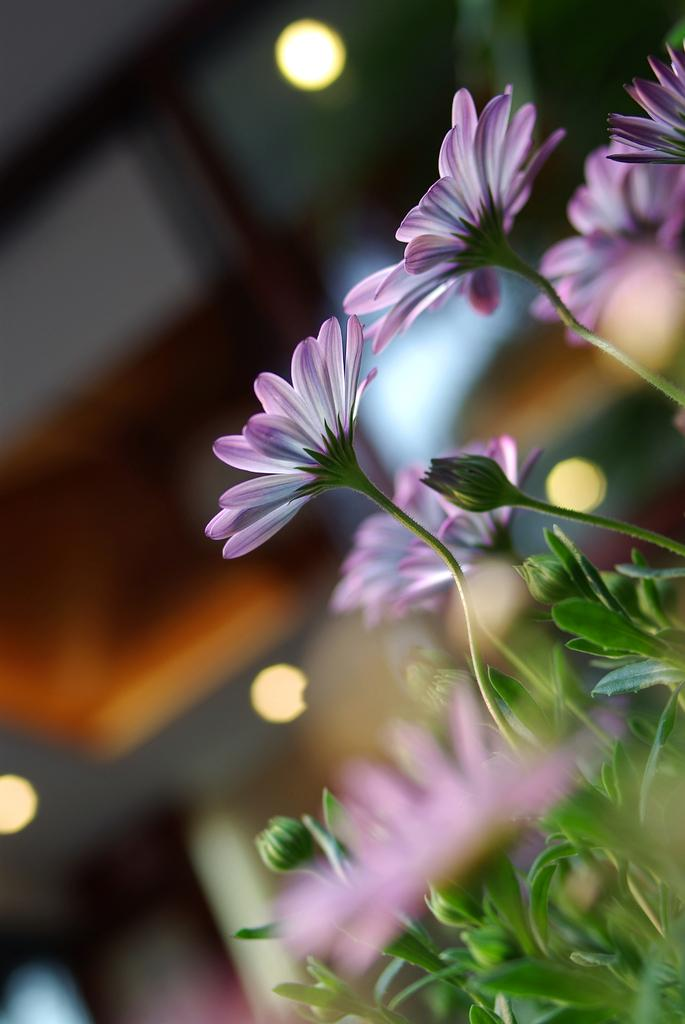What is the main subject of the image? The main subject of the image is plants and flowers in pink and white colors. What can be seen in the background of the image? In the background, there is a wall, a roof, lights, and a few other objects. What colors are the plants and flowers in the image? The plants and flowers are in pink and white colors. What type of punishment is being given to the son in the image? There is no son or punishment present in the image; it features plants and flowers in pink and white colors with a background of a wall, roof, lights, and a few other objects. 